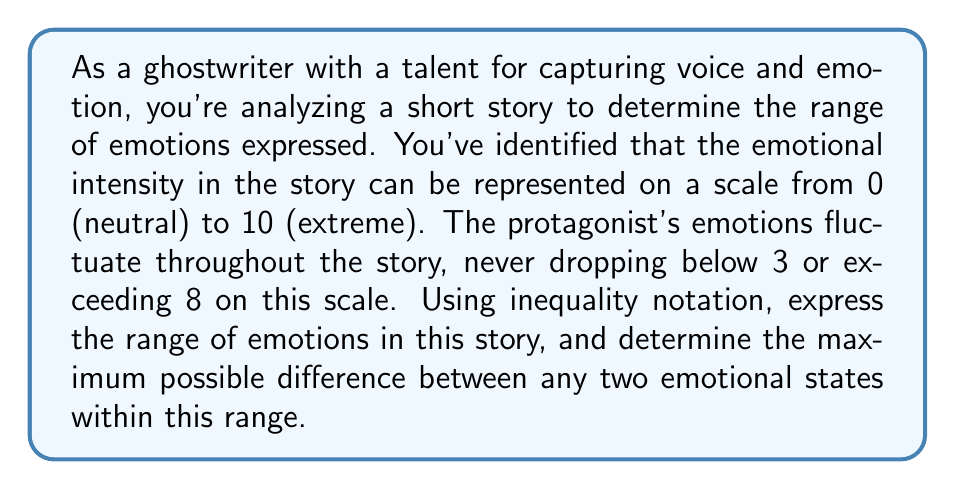Provide a solution to this math problem. To solve this problem, we'll follow these steps:

1. Express the range of emotions using inequality notation:
   The emotions never drop below 3 or exceed 8, so we can express this as:
   $$ 3 \leq x \leq 8 $$
   where $x$ represents the emotional intensity at any point in the story.

2. Determine the maximum possible difference between any two emotional states:
   - The lowest possible emotional state is 3
   - The highest possible emotional state is 8
   - The maximum difference would occur between these two extremes
   - To calculate the difference: $8 - 3 = 5$

Therefore, the maximum possible difference between any two emotional states is 5 units on the emotional intensity scale.

This analysis allows us to quantify the emotional range and volatility in the story, which is crucial for a ghostwriter aiming to capture the voice and emotion accurately.
Answer: Range of emotions: $3 \leq x \leq 8$
Maximum difference between emotional states: $5$ 